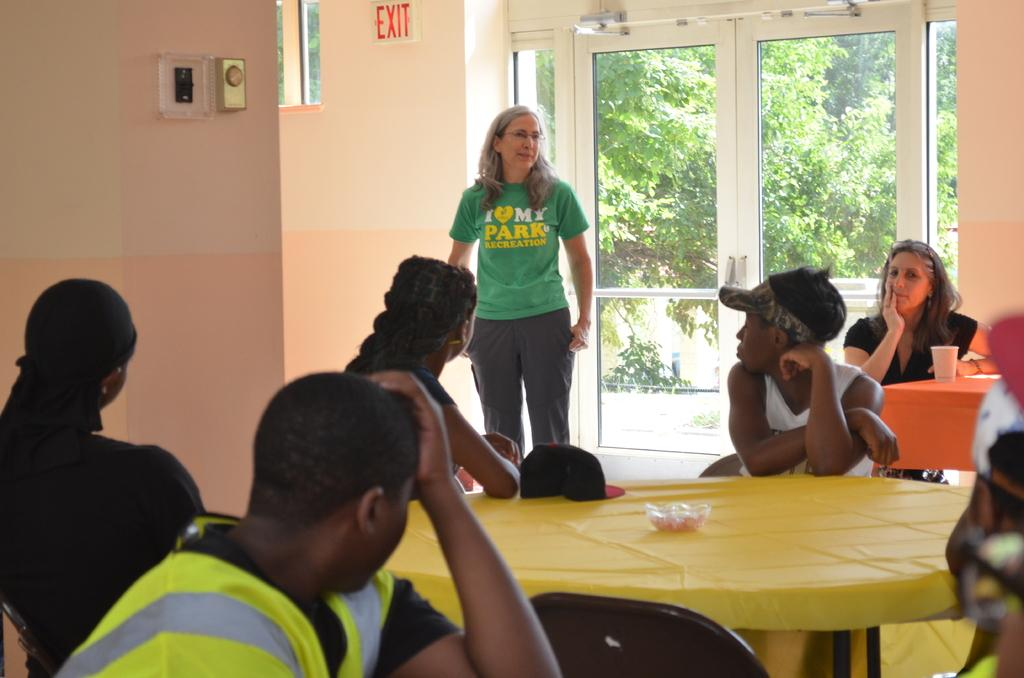What are the people in the image doing? The people in the image are sitting on chairs. chairs. What is the woman in the image doing? The woman is standing in the image. What are the people looking at in the image? The people are looking at the woman. What furniture is present in the image? There is a table in the image. What objects are on the table in the image? There is a glass and a bowl on the table in the image. What type of wine is being served in the image? There is no wine present in the image. Are the people wearing mittens in the image? There is no mention of mittens in the image. 